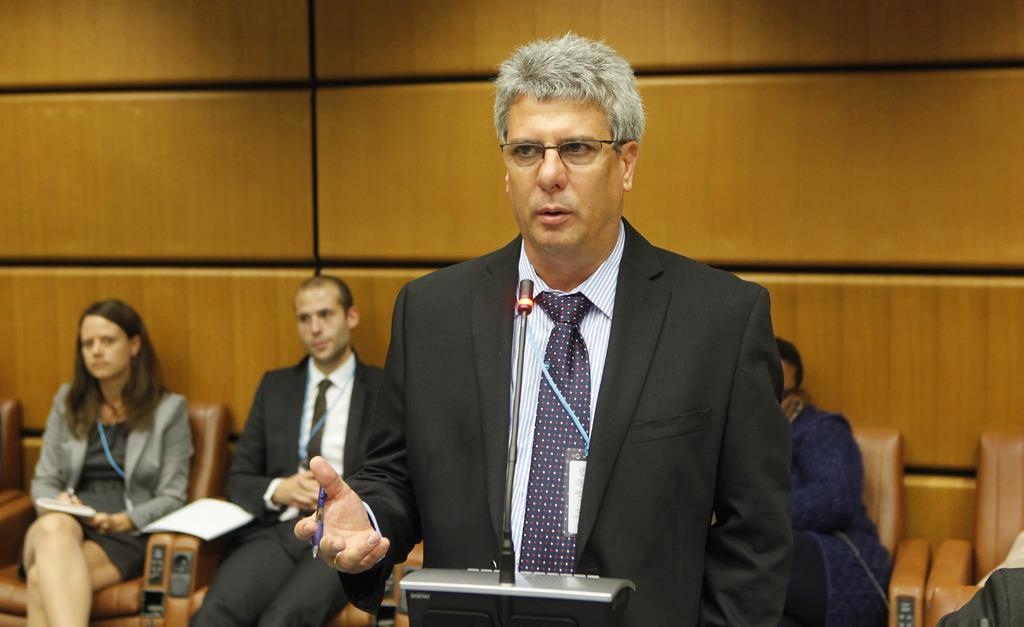Could you give a brief overview of what you see in this image? In the picture we can see a man standing and talking in the microphone which is on the stand, he is wearing a black color blazer with tie and shirt and in the background we can see some people are sitting on the chairs near the wall. 